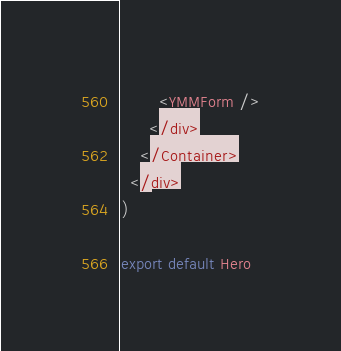Convert code to text. <code><loc_0><loc_0><loc_500><loc_500><_TypeScript_>        <YMMForm />
      </div>
    </Container>
  </div>
)

export default Hero
</code> 